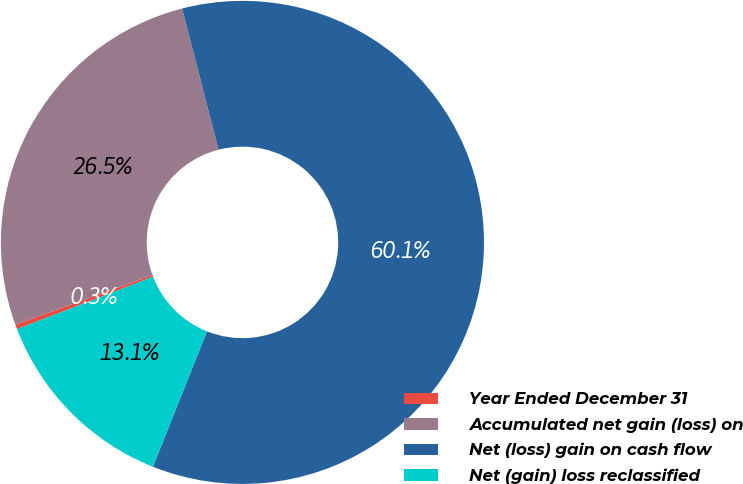Convert chart. <chart><loc_0><loc_0><loc_500><loc_500><pie_chart><fcel>Year Ended December 31<fcel>Accumulated net gain (loss) on<fcel>Net (loss) gain on cash flow<fcel>Net (gain) loss reclassified<nl><fcel>0.32%<fcel>26.51%<fcel>60.06%<fcel>13.11%<nl></chart> 